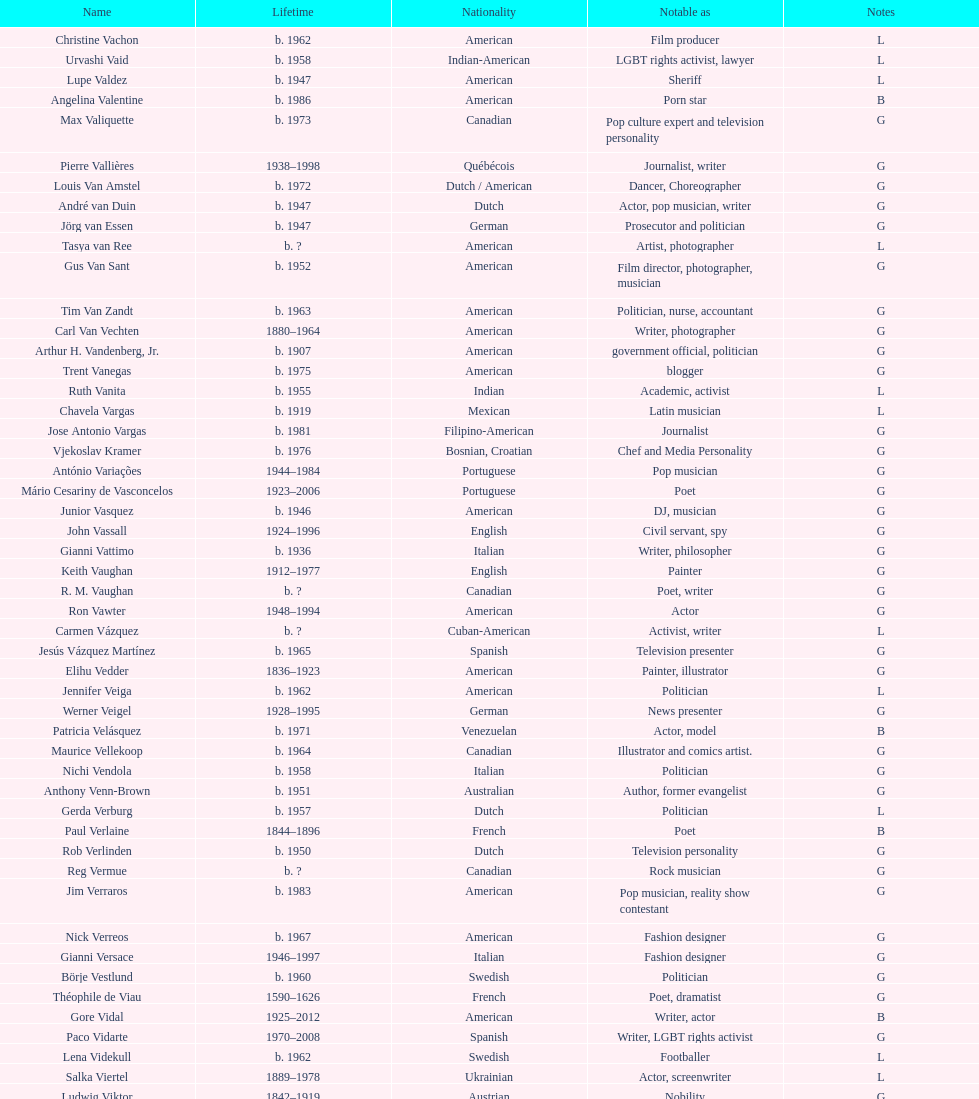Which ethnicity produced the most renowned poets? French. Give me the full table as a dictionary. {'header': ['Name', 'Lifetime', 'Nationality', 'Notable as', 'Notes'], 'rows': [['Christine Vachon', 'b. 1962', 'American', 'Film producer', 'L'], ['Urvashi Vaid', 'b. 1958', 'Indian-American', 'LGBT rights activist, lawyer', 'L'], ['Lupe Valdez', 'b. 1947', 'American', 'Sheriff', 'L'], ['Angelina Valentine', 'b. 1986', 'American', 'Porn star', 'B'], ['Max Valiquette', 'b. 1973', 'Canadian', 'Pop culture expert and television personality', 'G'], ['Pierre Vallières', '1938–1998', 'Québécois', 'Journalist, writer', 'G'], ['Louis Van Amstel', 'b. 1972', 'Dutch / American', 'Dancer, Choreographer', 'G'], ['André van Duin', 'b. 1947', 'Dutch', 'Actor, pop musician, writer', 'G'], ['Jörg van Essen', 'b. 1947', 'German', 'Prosecutor and politician', 'G'], ['Tasya van Ree', 'b.\xa0?', 'American', 'Artist, photographer', 'L'], ['Gus Van Sant', 'b. 1952', 'American', 'Film director, photographer, musician', 'G'], ['Tim Van Zandt', 'b. 1963', 'American', 'Politician, nurse, accountant', 'G'], ['Carl Van Vechten', '1880–1964', 'American', 'Writer, photographer', 'G'], ['Arthur H. Vandenberg, Jr.', 'b. 1907', 'American', 'government official, politician', 'G'], ['Trent Vanegas', 'b. 1975', 'American', 'blogger', 'G'], ['Ruth Vanita', 'b. 1955', 'Indian', 'Academic, activist', 'L'], ['Chavela Vargas', 'b. 1919', 'Mexican', 'Latin musician', 'L'], ['Jose Antonio Vargas', 'b. 1981', 'Filipino-American', 'Journalist', 'G'], ['Vjekoslav Kramer', 'b. 1976', 'Bosnian, Croatian', 'Chef and Media Personality', 'G'], ['António Variações', '1944–1984', 'Portuguese', 'Pop musician', 'G'], ['Mário Cesariny de Vasconcelos', '1923–2006', 'Portuguese', 'Poet', 'G'], ['Junior Vasquez', 'b. 1946', 'American', 'DJ, musician', 'G'], ['John Vassall', '1924–1996', 'English', 'Civil servant, spy', 'G'], ['Gianni Vattimo', 'b. 1936', 'Italian', 'Writer, philosopher', 'G'], ['Keith Vaughan', '1912–1977', 'English', 'Painter', 'G'], ['R. M. Vaughan', 'b.\xa0?', 'Canadian', 'Poet, writer', 'G'], ['Ron Vawter', '1948–1994', 'American', 'Actor', 'G'], ['Carmen Vázquez', 'b.\xa0?', 'Cuban-American', 'Activist, writer', 'L'], ['Jesús Vázquez Martínez', 'b. 1965', 'Spanish', 'Television presenter', 'G'], ['Elihu Vedder', '1836–1923', 'American', 'Painter, illustrator', 'G'], ['Jennifer Veiga', 'b. 1962', 'American', 'Politician', 'L'], ['Werner Veigel', '1928–1995', 'German', 'News presenter', 'G'], ['Patricia Velásquez', 'b. 1971', 'Venezuelan', 'Actor, model', 'B'], ['Maurice Vellekoop', 'b. 1964', 'Canadian', 'Illustrator and comics artist.', 'G'], ['Nichi Vendola', 'b. 1958', 'Italian', 'Politician', 'G'], ['Anthony Venn-Brown', 'b. 1951', 'Australian', 'Author, former evangelist', 'G'], ['Gerda Verburg', 'b. 1957', 'Dutch', 'Politician', 'L'], ['Paul Verlaine', '1844–1896', 'French', 'Poet', 'B'], ['Rob Verlinden', 'b. 1950', 'Dutch', 'Television personality', 'G'], ['Reg Vermue', 'b.\xa0?', 'Canadian', 'Rock musician', 'G'], ['Jim Verraros', 'b. 1983', 'American', 'Pop musician, reality show contestant', 'G'], ['Nick Verreos', 'b. 1967', 'American', 'Fashion designer', 'G'], ['Gianni Versace', '1946–1997', 'Italian', 'Fashion designer', 'G'], ['Börje Vestlund', 'b. 1960', 'Swedish', 'Politician', 'G'], ['Théophile de Viau', '1590–1626', 'French', 'Poet, dramatist', 'G'], ['Gore Vidal', '1925–2012', 'American', 'Writer, actor', 'B'], ['Paco Vidarte', '1970–2008', 'Spanish', 'Writer, LGBT rights activist', 'G'], ['Lena Videkull', 'b. 1962', 'Swedish', 'Footballer', 'L'], ['Salka Viertel', '1889–1978', 'Ukrainian', 'Actor, screenwriter', 'L'], ['Ludwig Viktor', '1842–1919', 'Austrian', 'Nobility', 'G'], ['Bruce Vilanch', 'b. 1948', 'American', 'Comedy writer, actor', 'G'], ['Tom Villard', '1953–1994', 'American', 'Actor', 'G'], ['José Villarrubia', 'b. 1961', 'American', 'Artist', 'G'], ['Xavier Villaurrutia', '1903–1950', 'Mexican', 'Poet, playwright', 'G'], ["Alain-Philippe Malagnac d'Argens de Villèle", '1950–2000', 'French', 'Aristocrat', 'G'], ['Norah Vincent', 'b.\xa0?', 'American', 'Journalist', 'L'], ['Donald Vining', '1917–1998', 'American', 'Writer', 'G'], ['Luchino Visconti', '1906–1976', 'Italian', 'Filmmaker', 'G'], ['Pavel Vítek', 'b. 1962', 'Czech', 'Pop musician, actor', 'G'], ['Renée Vivien', '1877–1909', 'English', 'Poet', 'L'], ['Claude Vivier', '1948–1983', 'Canadian', '20th century classical composer', 'G'], ['Taylor Vixen', 'b. 1983', 'American', 'Porn star', 'B'], ['Bruce Voeller', '1934–1994', 'American', 'HIV/AIDS researcher', 'G'], ['Paula Vogel', 'b. 1951', 'American', 'Playwright', 'L'], ['Julia Volkova', 'b. 1985', 'Russian', 'Singer', 'B'], ['Jörg van Essen', 'b. 1947', 'German', 'Politician', 'G'], ['Ole von Beust', 'b. 1955', 'German', 'Politician', 'G'], ['Wilhelm von Gloeden', '1856–1931', 'German', 'Photographer', 'G'], ['Rosa von Praunheim', 'b. 1942', 'German', 'Film director', 'G'], ['Kurt von Ruffin', 'b. 1901–1996', 'German', 'Holocaust survivor', 'G'], ['Hella von Sinnen', 'b. 1959', 'German', 'Comedian', 'L'], ['Daniel Vosovic', 'b. 1981', 'American', 'Fashion designer', 'G'], ['Delwin Vriend', 'b. 1966', 'Canadian', 'LGBT rights activist', 'G']]} 